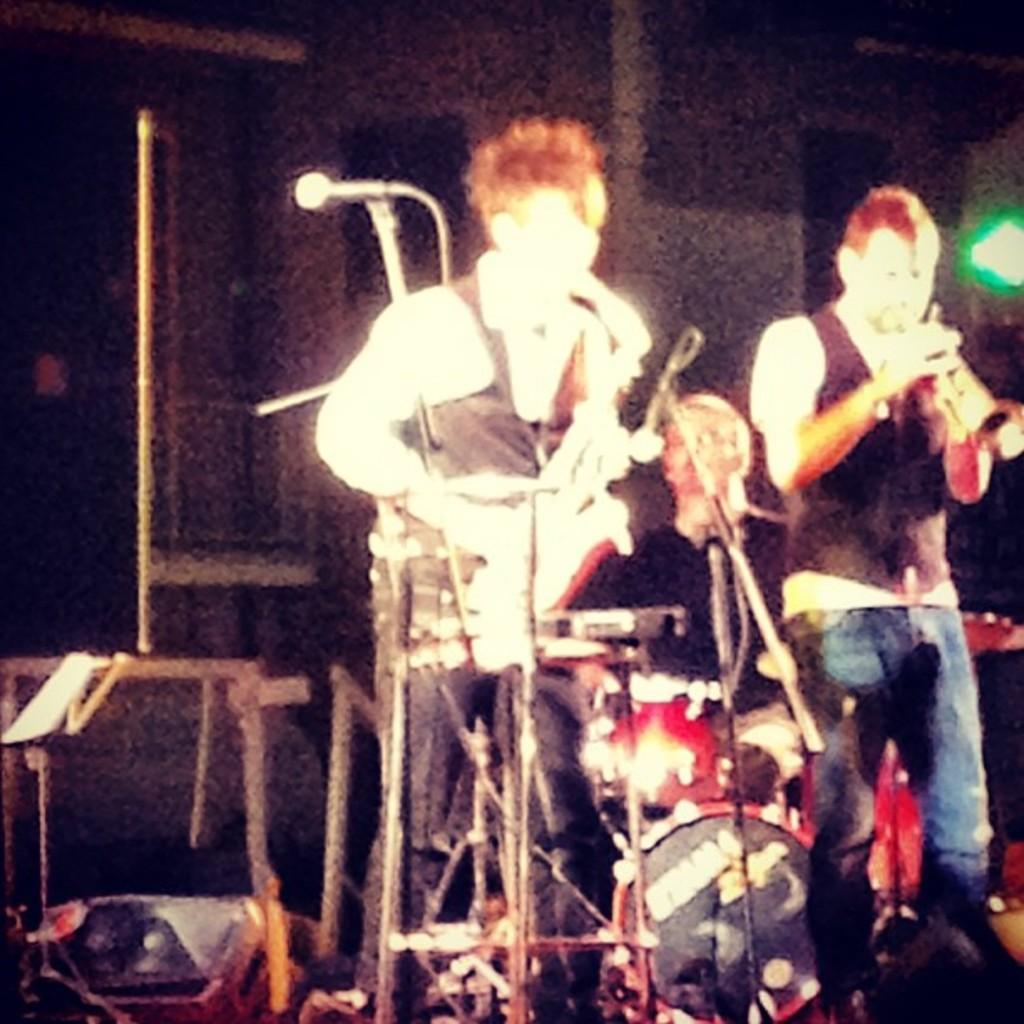How many people are in the image? There are two persons in the image. What are the persons doing in the image? The persons are standing and playing musical instruments. What is the color of the background in the image? The background of the image is black. Can you describe the lighting in the image? There is light visible in the image. What additional equipment can be seen in the image? There are microphones (mics) and stands in the image. What type of letters are being exchanged between the two persons in the image? There are no letters being exchanged in the image; the two persons are playing musical instruments. How does the comfort of the chairs affect the performance of the musicians in the image? There are no chairs present in the image, so the comfort of chairs cannot affect the performance of the musicians. 